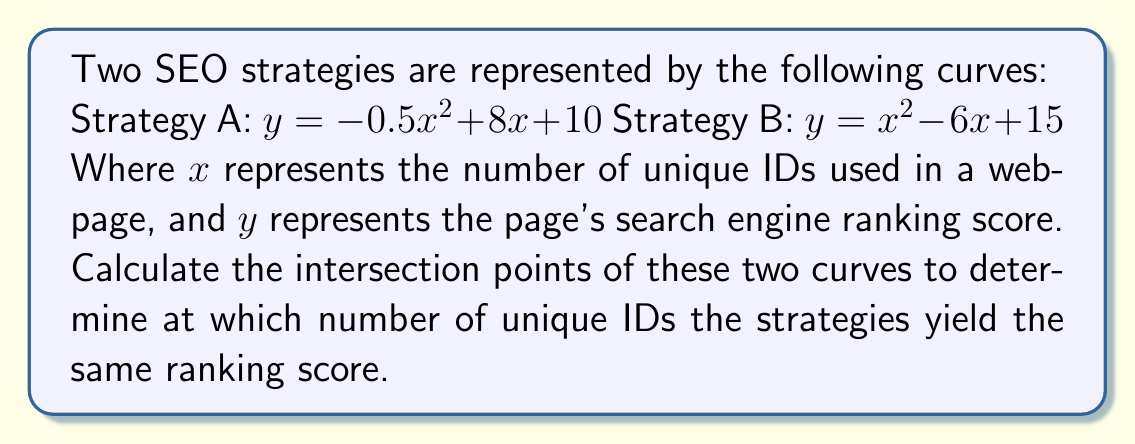Can you answer this question? To find the intersection points, we need to solve the equation where both curves are equal:

1) Set the equations equal to each other:
   $-0.5x^2 + 8x + 10 = x^2 - 6x + 15$

2) Rearrange the equation to standard form:
   $1.5x^2 - 14x + 5 = 0$

3) This is a quadratic equation in the form $ax^2 + bx + c = 0$, where:
   $a = 1.5$
   $b = -14$
   $c = 5$

4) Use the quadratic formula: $x = \frac{-b \pm \sqrt{b^2 - 4ac}}{2a}$

5) Substitute the values:
   $x = \frac{14 \pm \sqrt{(-14)^2 - 4(1.5)(5)}}{2(1.5)}$

6) Simplify:
   $x = \frac{14 \pm \sqrt{196 - 30}}{3} = \frac{14 \pm \sqrt{166}}{3}$

7) Calculate the two solutions:
   $x_1 = \frac{14 + \sqrt{166}}{3} \approx 8.29$
   $x_2 = \frac{14 - \sqrt{166}}{3} \approx 1.04$

8) To find the y-coordinates, substitute either x value into one of the original equations:
   For $x_1$: $y = -0.5(8.29)^2 + 8(8.29) + 10 \approx 42.29$
   For $x_2$: $y = -0.5(1.04)^2 + 8(1.04) + 10 \approx 18.27$

Therefore, the intersection points are approximately (8.29, 42.29) and (1.04, 18.27).
Answer: (8.29, 42.29) and (1.04, 18.27) 